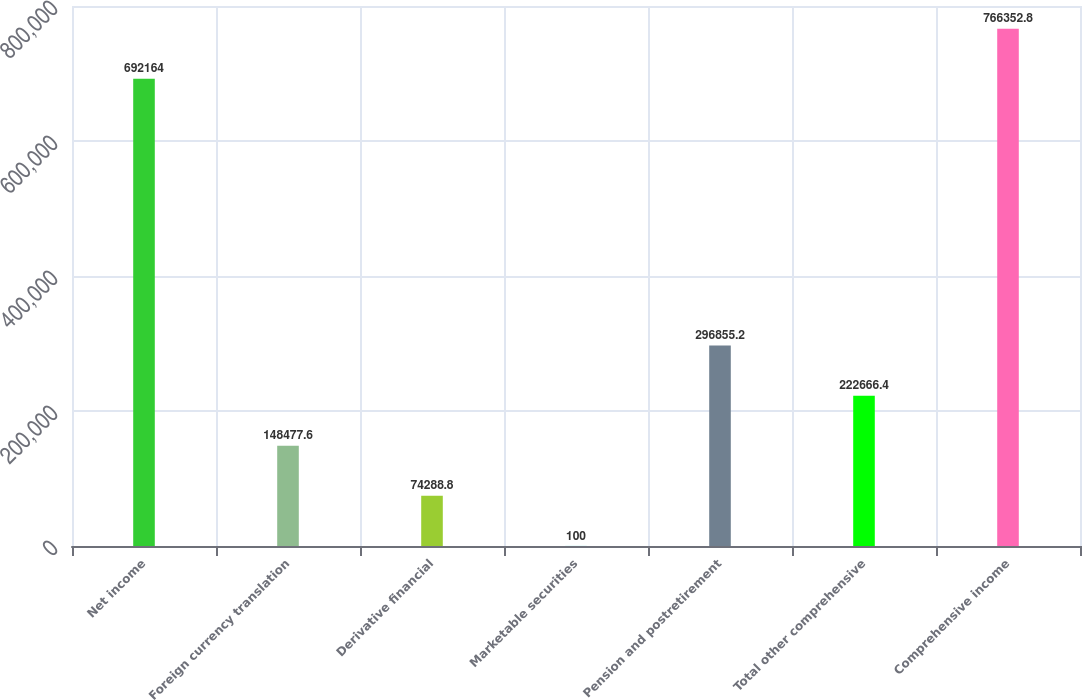<chart> <loc_0><loc_0><loc_500><loc_500><bar_chart><fcel>Net income<fcel>Foreign currency translation<fcel>Derivative financial<fcel>Marketable securities<fcel>Pension and postretirement<fcel>Total other comprehensive<fcel>Comprehensive income<nl><fcel>692164<fcel>148478<fcel>74288.8<fcel>100<fcel>296855<fcel>222666<fcel>766353<nl></chart> 